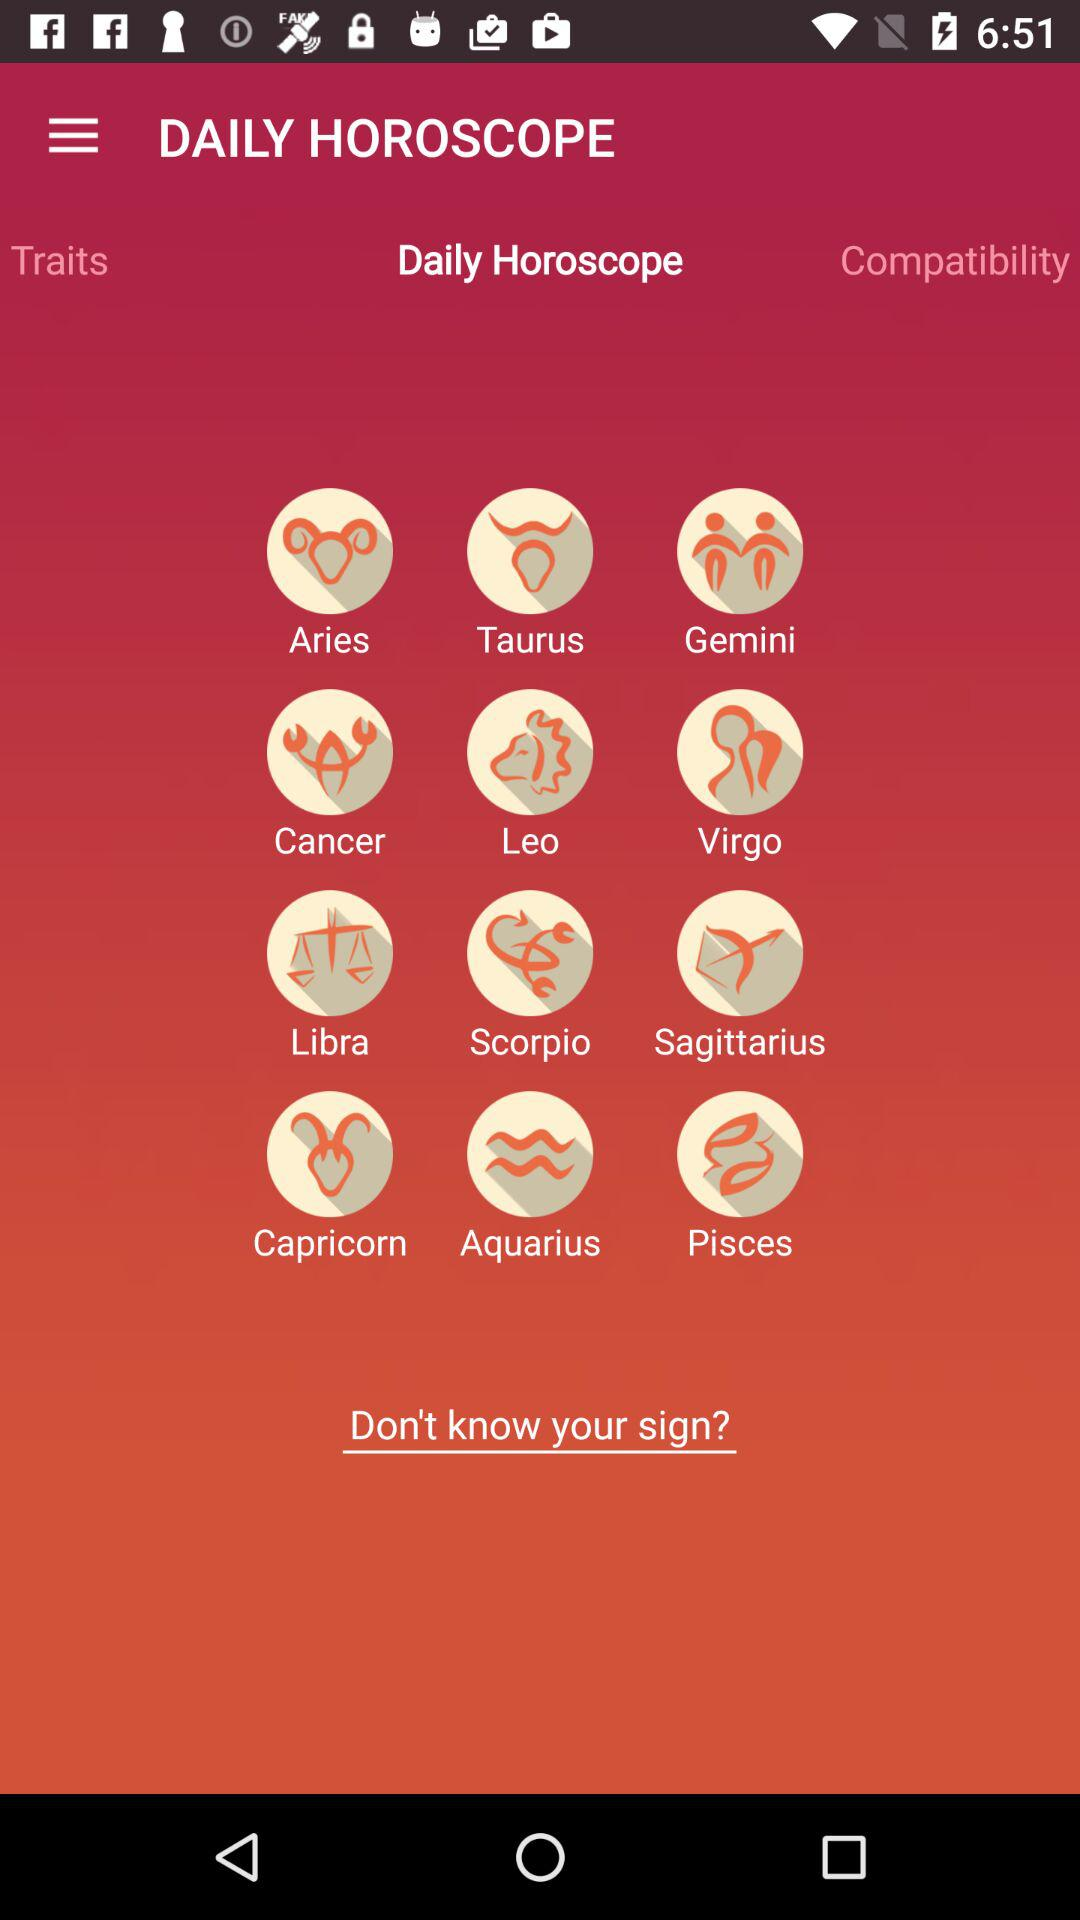Which tab is selected? The selected tab is "Daily Horoscope". 